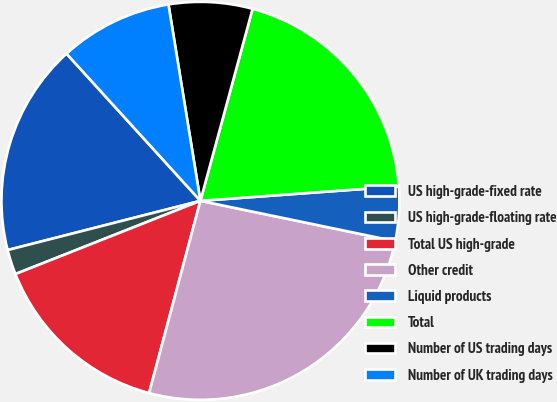Convert chart. <chart><loc_0><loc_0><loc_500><loc_500><pie_chart><fcel>US high-grade-fixed rate<fcel>US high-grade-floating rate<fcel>Total US high-grade<fcel>Other credit<fcel>Liquid products<fcel>Total<fcel>Number of US trading days<fcel>Number of UK trading days<nl><fcel>17.23%<fcel>2.02%<fcel>14.85%<fcel>25.9%<fcel>4.41%<fcel>19.62%<fcel>6.79%<fcel>9.18%<nl></chart> 